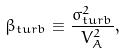<formula> <loc_0><loc_0><loc_500><loc_500>\beta _ { t u r b } \equiv \frac { \sigma _ { t u r b } ^ { 2 } } { V _ { A } ^ { 2 } } ,</formula> 